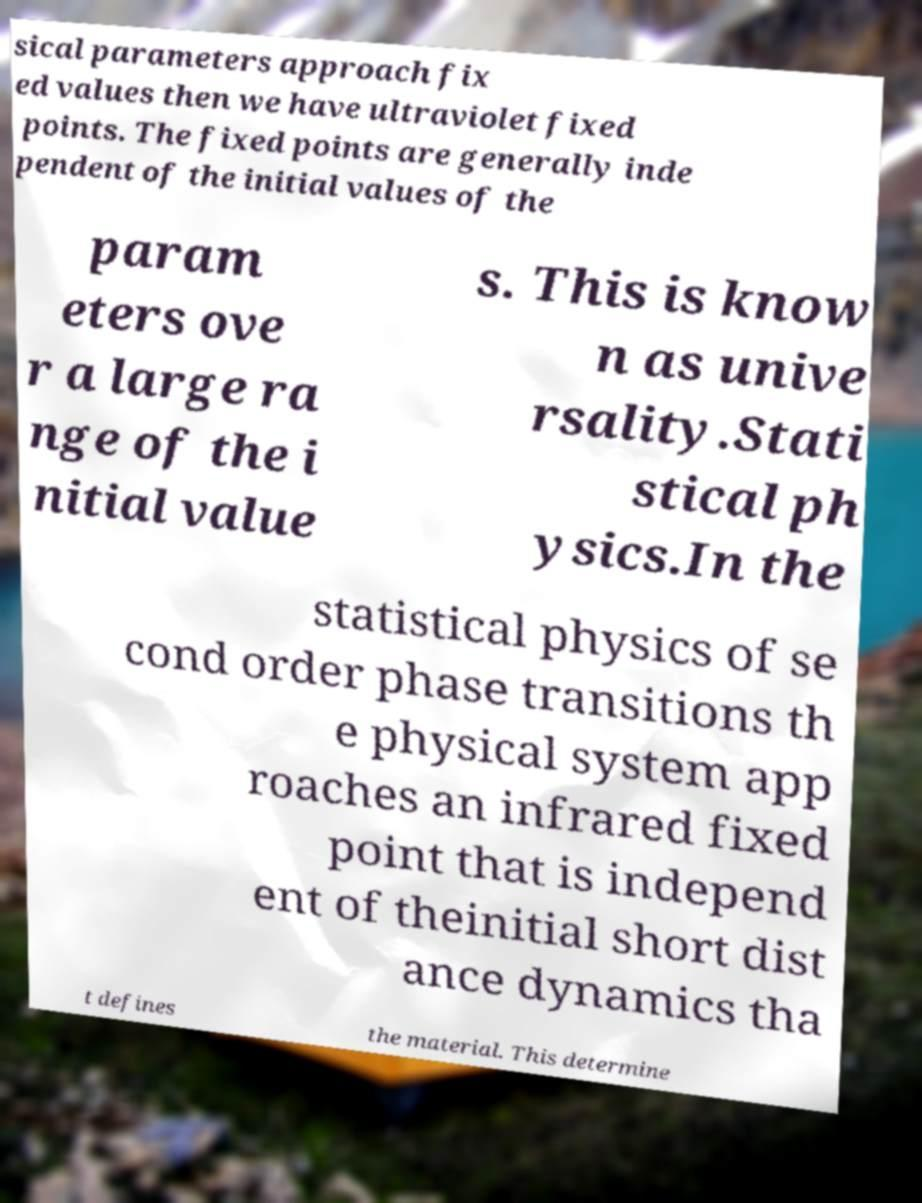Could you extract and type out the text from this image? sical parameters approach fix ed values then we have ultraviolet fixed points. The fixed points are generally inde pendent of the initial values of the param eters ove r a large ra nge of the i nitial value s. This is know n as unive rsality.Stati stical ph ysics.In the statistical physics of se cond order phase transitions th e physical system app roaches an infrared fixed point that is independ ent of theinitial short dist ance dynamics tha t defines the material. This determine 